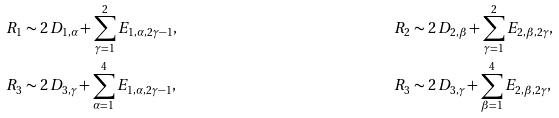Convert formula to latex. <formula><loc_0><loc_0><loc_500><loc_500>R _ { 1 } & \sim 2 \, D _ { 1 , \alpha } + \sum _ { \gamma = 1 } ^ { 2 } E _ { 1 , \alpha , 2 \gamma - 1 } , & R _ { 2 } & \sim 2 \, D _ { 2 , \beta } + \sum _ { \gamma = 1 } ^ { 2 } E _ { 2 , \beta , 2 \gamma } , \\ R _ { 3 } & \sim 2 \, D _ { 3 , \gamma } + \sum _ { \alpha = 1 } ^ { 4 } E _ { 1 , \alpha , 2 \gamma - 1 } , & R _ { 3 } & \sim 2 \, D _ { 3 , \gamma } + \sum _ { \beta = 1 } ^ { 4 } E _ { 2 , \beta , 2 \gamma } ,</formula> 